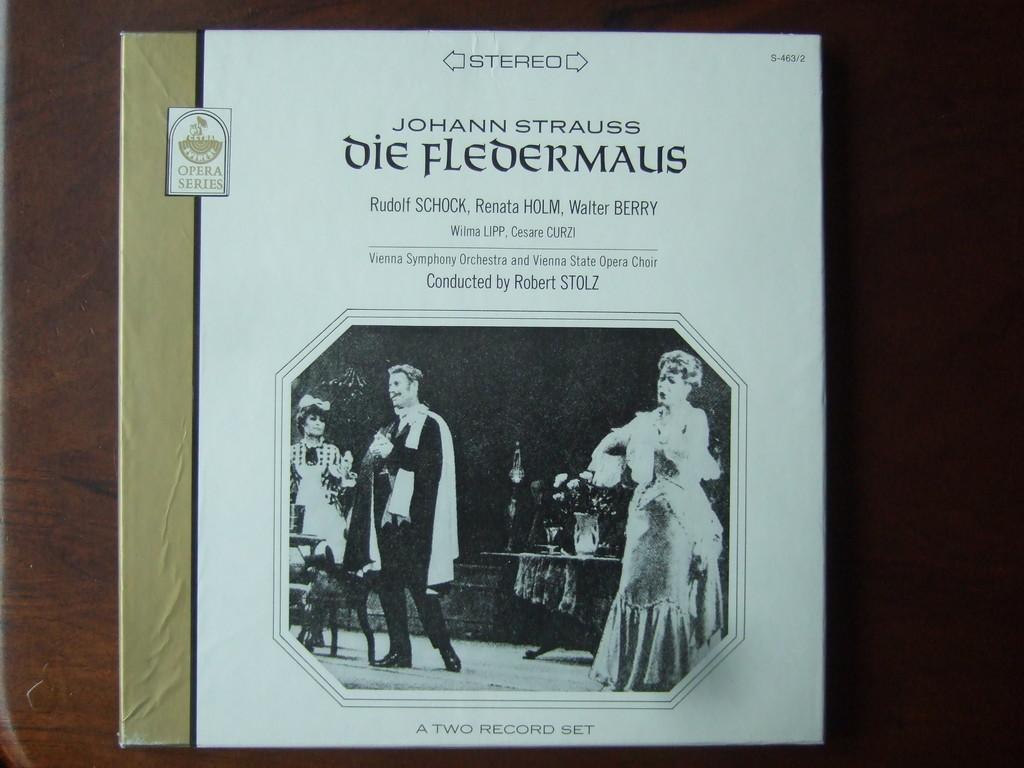How many records are in this set?
Give a very brief answer. Two. 